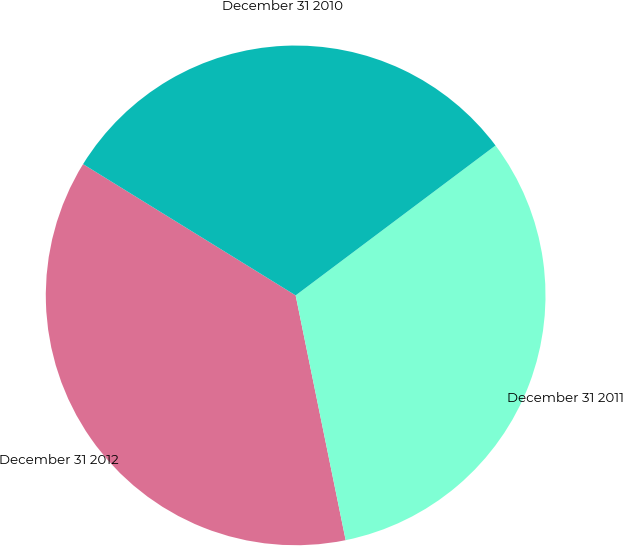<chart> <loc_0><loc_0><loc_500><loc_500><pie_chart><fcel>December 31 2012<fcel>December 31 2011<fcel>December 31 2010<nl><fcel>37.01%<fcel>32.03%<fcel>30.95%<nl></chart> 